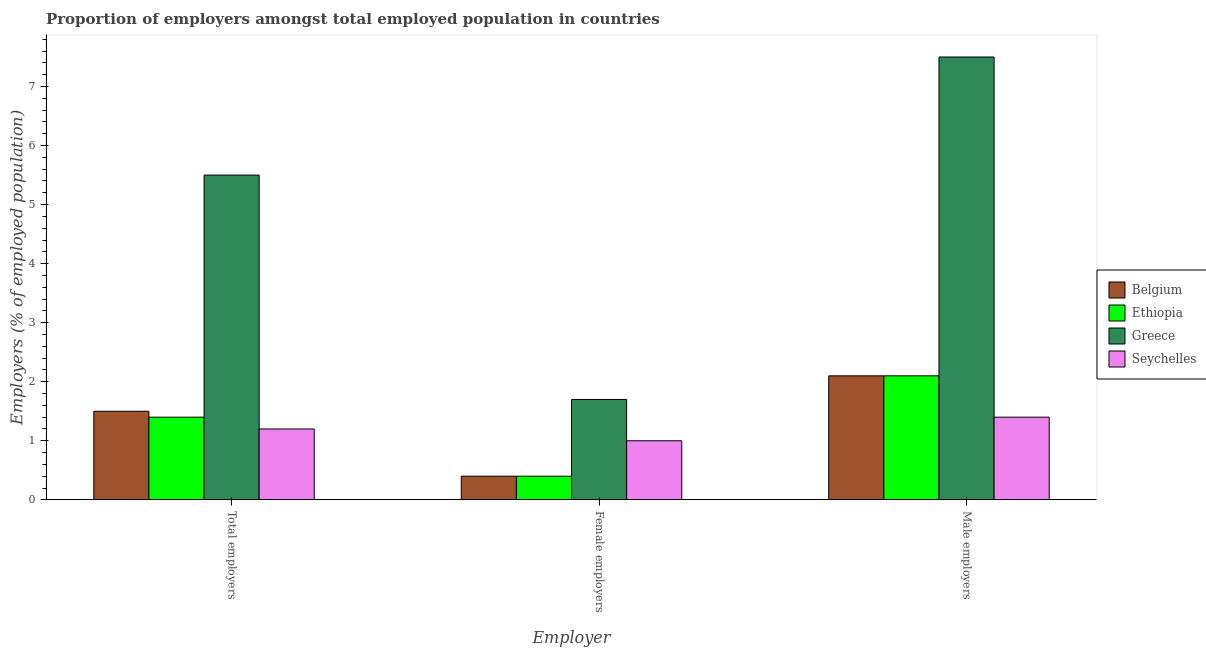Are the number of bars per tick equal to the number of legend labels?
Your response must be concise. Yes. How many bars are there on the 3rd tick from the left?
Make the answer very short. 4. What is the label of the 2nd group of bars from the left?
Provide a succinct answer. Female employers. What is the percentage of female employers in Belgium?
Offer a very short reply. 0.4. Across all countries, what is the maximum percentage of male employers?
Offer a terse response. 7.5. Across all countries, what is the minimum percentage of female employers?
Your response must be concise. 0.4. In which country was the percentage of female employers maximum?
Your answer should be very brief. Greece. What is the total percentage of total employers in the graph?
Ensure brevity in your answer.  9.6. What is the difference between the percentage of female employers in Greece and that in Seychelles?
Keep it short and to the point. 0.7. What is the difference between the percentage of male employers in Ethiopia and the percentage of female employers in Seychelles?
Provide a succinct answer. 1.1. What is the average percentage of male employers per country?
Your response must be concise. 3.27. What is the difference between the percentage of female employers and percentage of total employers in Belgium?
Provide a short and direct response. -1.1. In how many countries, is the percentage of male employers greater than 6 %?
Make the answer very short. 1. What is the ratio of the percentage of female employers in Seychelles to that in Belgium?
Your answer should be very brief. 2.5. What is the difference between the highest and the second highest percentage of male employers?
Your response must be concise. 5.4. What is the difference between the highest and the lowest percentage of total employers?
Ensure brevity in your answer.  4.3. Is the sum of the percentage of female employers in Greece and Belgium greater than the maximum percentage of male employers across all countries?
Your answer should be very brief. No. What does the 2nd bar from the left in Total employers represents?
Offer a terse response. Ethiopia. What does the 2nd bar from the right in Total employers represents?
Provide a succinct answer. Greece. How many countries are there in the graph?
Provide a succinct answer. 4. Are the values on the major ticks of Y-axis written in scientific E-notation?
Provide a short and direct response. No. Does the graph contain grids?
Offer a terse response. No. What is the title of the graph?
Offer a terse response. Proportion of employers amongst total employed population in countries. Does "Sub-Saharan Africa (developing only)" appear as one of the legend labels in the graph?
Provide a short and direct response. No. What is the label or title of the X-axis?
Keep it short and to the point. Employer. What is the label or title of the Y-axis?
Your response must be concise. Employers (% of employed population). What is the Employers (% of employed population) in Belgium in Total employers?
Provide a short and direct response. 1.5. What is the Employers (% of employed population) in Ethiopia in Total employers?
Ensure brevity in your answer.  1.4. What is the Employers (% of employed population) of Greece in Total employers?
Offer a terse response. 5.5. What is the Employers (% of employed population) of Seychelles in Total employers?
Provide a succinct answer. 1.2. What is the Employers (% of employed population) in Belgium in Female employers?
Offer a terse response. 0.4. What is the Employers (% of employed population) in Ethiopia in Female employers?
Make the answer very short. 0.4. What is the Employers (% of employed population) of Greece in Female employers?
Your answer should be very brief. 1.7. What is the Employers (% of employed population) of Belgium in Male employers?
Offer a terse response. 2.1. What is the Employers (% of employed population) in Ethiopia in Male employers?
Offer a very short reply. 2.1. What is the Employers (% of employed population) in Greece in Male employers?
Offer a very short reply. 7.5. What is the Employers (% of employed population) of Seychelles in Male employers?
Your answer should be very brief. 1.4. Across all Employer, what is the maximum Employers (% of employed population) of Belgium?
Provide a succinct answer. 2.1. Across all Employer, what is the maximum Employers (% of employed population) in Ethiopia?
Keep it short and to the point. 2.1. Across all Employer, what is the maximum Employers (% of employed population) in Seychelles?
Your response must be concise. 1.4. Across all Employer, what is the minimum Employers (% of employed population) of Belgium?
Give a very brief answer. 0.4. Across all Employer, what is the minimum Employers (% of employed population) in Ethiopia?
Make the answer very short. 0.4. Across all Employer, what is the minimum Employers (% of employed population) in Greece?
Provide a succinct answer. 1.7. What is the total Employers (% of employed population) in Seychelles in the graph?
Your answer should be very brief. 3.6. What is the difference between the Employers (% of employed population) in Belgium in Total employers and that in Female employers?
Keep it short and to the point. 1.1. What is the difference between the Employers (% of employed population) of Ethiopia in Total employers and that in Female employers?
Ensure brevity in your answer.  1. What is the difference between the Employers (% of employed population) in Seychelles in Total employers and that in Female employers?
Offer a very short reply. 0.2. What is the difference between the Employers (% of employed population) of Greece in Total employers and that in Male employers?
Ensure brevity in your answer.  -2. What is the difference between the Employers (% of employed population) of Seychelles in Total employers and that in Male employers?
Your answer should be compact. -0.2. What is the difference between the Employers (% of employed population) in Belgium in Female employers and that in Male employers?
Provide a short and direct response. -1.7. What is the difference between the Employers (% of employed population) in Ethiopia in Female employers and that in Male employers?
Ensure brevity in your answer.  -1.7. What is the difference between the Employers (% of employed population) in Seychelles in Female employers and that in Male employers?
Your answer should be compact. -0.4. What is the difference between the Employers (% of employed population) of Ethiopia in Total employers and the Employers (% of employed population) of Greece in Female employers?
Offer a very short reply. -0.3. What is the difference between the Employers (% of employed population) in Ethiopia in Total employers and the Employers (% of employed population) in Seychelles in Female employers?
Provide a succinct answer. 0.4. What is the difference between the Employers (% of employed population) of Belgium in Total employers and the Employers (% of employed population) of Ethiopia in Male employers?
Ensure brevity in your answer.  -0.6. What is the difference between the Employers (% of employed population) of Belgium in Female employers and the Employers (% of employed population) of Ethiopia in Male employers?
Provide a short and direct response. -1.7. What is the difference between the Employers (% of employed population) in Belgium in Female employers and the Employers (% of employed population) in Greece in Male employers?
Ensure brevity in your answer.  -7.1. What is the difference between the Employers (% of employed population) of Greece in Female employers and the Employers (% of employed population) of Seychelles in Male employers?
Make the answer very short. 0.3. What is the average Employers (% of employed population) in Ethiopia per Employer?
Your answer should be compact. 1.3. What is the average Employers (% of employed population) of Greece per Employer?
Give a very brief answer. 4.9. What is the average Employers (% of employed population) in Seychelles per Employer?
Ensure brevity in your answer.  1.2. What is the difference between the Employers (% of employed population) of Belgium and Employers (% of employed population) of Ethiopia in Total employers?
Keep it short and to the point. 0.1. What is the difference between the Employers (% of employed population) of Belgium and Employers (% of employed population) of Ethiopia in Female employers?
Give a very brief answer. 0. What is the difference between the Employers (% of employed population) in Belgium and Employers (% of employed population) in Seychelles in Female employers?
Your answer should be very brief. -0.6. What is the difference between the Employers (% of employed population) in Belgium and Employers (% of employed population) in Ethiopia in Male employers?
Your answer should be compact. 0. What is the difference between the Employers (% of employed population) of Belgium and Employers (% of employed population) of Greece in Male employers?
Give a very brief answer. -5.4. What is the difference between the Employers (% of employed population) of Belgium and Employers (% of employed population) of Seychelles in Male employers?
Your answer should be compact. 0.7. What is the difference between the Employers (% of employed population) in Ethiopia and Employers (% of employed population) in Seychelles in Male employers?
Provide a succinct answer. 0.7. What is the ratio of the Employers (% of employed population) in Belgium in Total employers to that in Female employers?
Give a very brief answer. 3.75. What is the ratio of the Employers (% of employed population) in Greece in Total employers to that in Female employers?
Offer a very short reply. 3.24. What is the ratio of the Employers (% of employed population) of Ethiopia in Total employers to that in Male employers?
Give a very brief answer. 0.67. What is the ratio of the Employers (% of employed population) of Greece in Total employers to that in Male employers?
Offer a very short reply. 0.73. What is the ratio of the Employers (% of employed population) in Belgium in Female employers to that in Male employers?
Your response must be concise. 0.19. What is the ratio of the Employers (% of employed population) of Ethiopia in Female employers to that in Male employers?
Ensure brevity in your answer.  0.19. What is the ratio of the Employers (% of employed population) in Greece in Female employers to that in Male employers?
Ensure brevity in your answer.  0.23. What is the ratio of the Employers (% of employed population) of Seychelles in Female employers to that in Male employers?
Make the answer very short. 0.71. What is the difference between the highest and the second highest Employers (% of employed population) of Greece?
Keep it short and to the point. 2. What is the difference between the highest and the lowest Employers (% of employed population) of Belgium?
Provide a succinct answer. 1.7. 